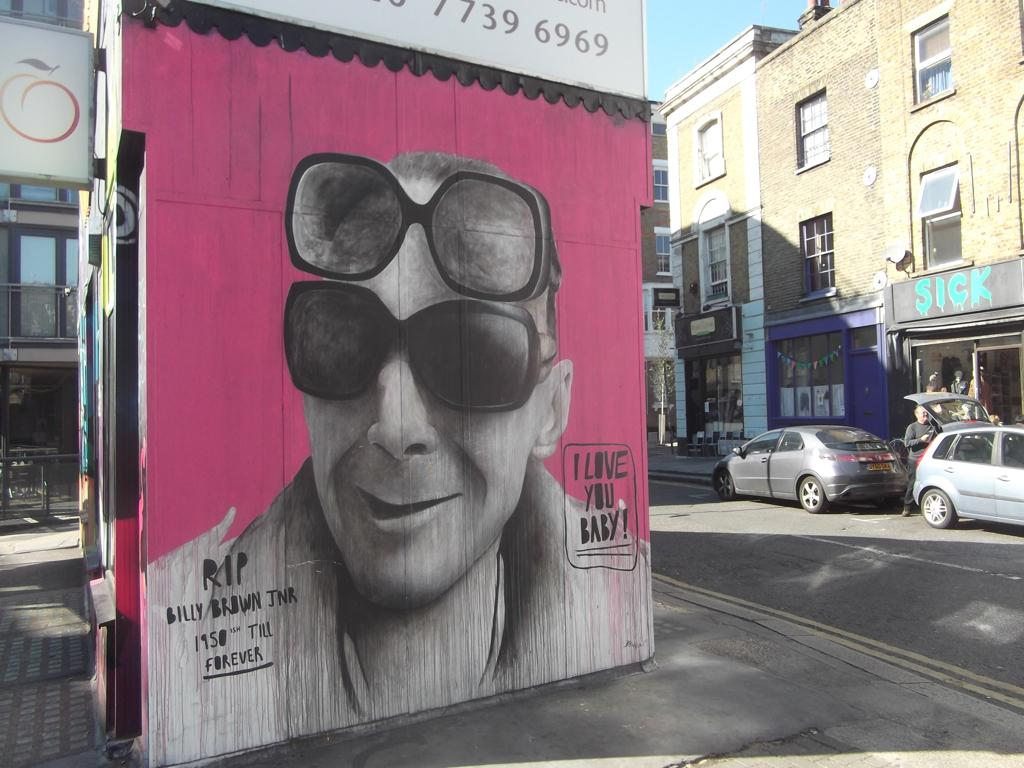What is depicted in the painting in the image? There is a painting of a person in the image. What is the person in the painting wearing? The person in the painting is wearing goggles. What can be seen on either side of the person in the painting? There is something written on either side of the person in the painting. How many cars are visible in the image? There are two cars in the image. What type of structures can be seen in the right corner of the image? There are buildings in the right corner of the image. What type of turkey is sitting on the person's shoulder in the painting? There is no turkey present in the painting or the image. How is the person's brother depicted in the painting? There is no mention of a brother in the painting or the image. 